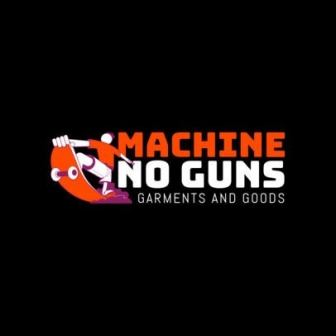Discuss how the visual elements of the logo complement its message. The visual elements of the logo are meticulously designed to complement and reinforce its message. The stark black background brings the bright orange and white elements into sharp focus, making the logo highly noticeable and impactful. The central cartoon character holding a gun, which is crossed out with the red prohibition symbol, immediately communicates the company's anti-gun stance. This simple yet powerful imagery ensures that the message is clear at a glance. The block letters of the company name, rendered in the sharegpt4v/same vibrant colors, further emphasize the strength and clarity of the message. The inclusion of 'Garments and Goods' in smaller white text below gives a succinct description of what the company offers, without distracting from the central theme. Collectively, these elements create a cohesive visual narrative that is both engaging and informative. What inspired the company's anti-gun stance? While I can't provide specific details about the company's founders, it's likely that 'Machine No Guns' was inspired by a desire to promote peace and safety in the community. Many companies adopt strong social stances based on the personal experiences and values of their founders. In this case, the pronounced anti-gun stance might be rooted in a commitment to reducing violence and fostering a culture of non-violence through their products and branding. 